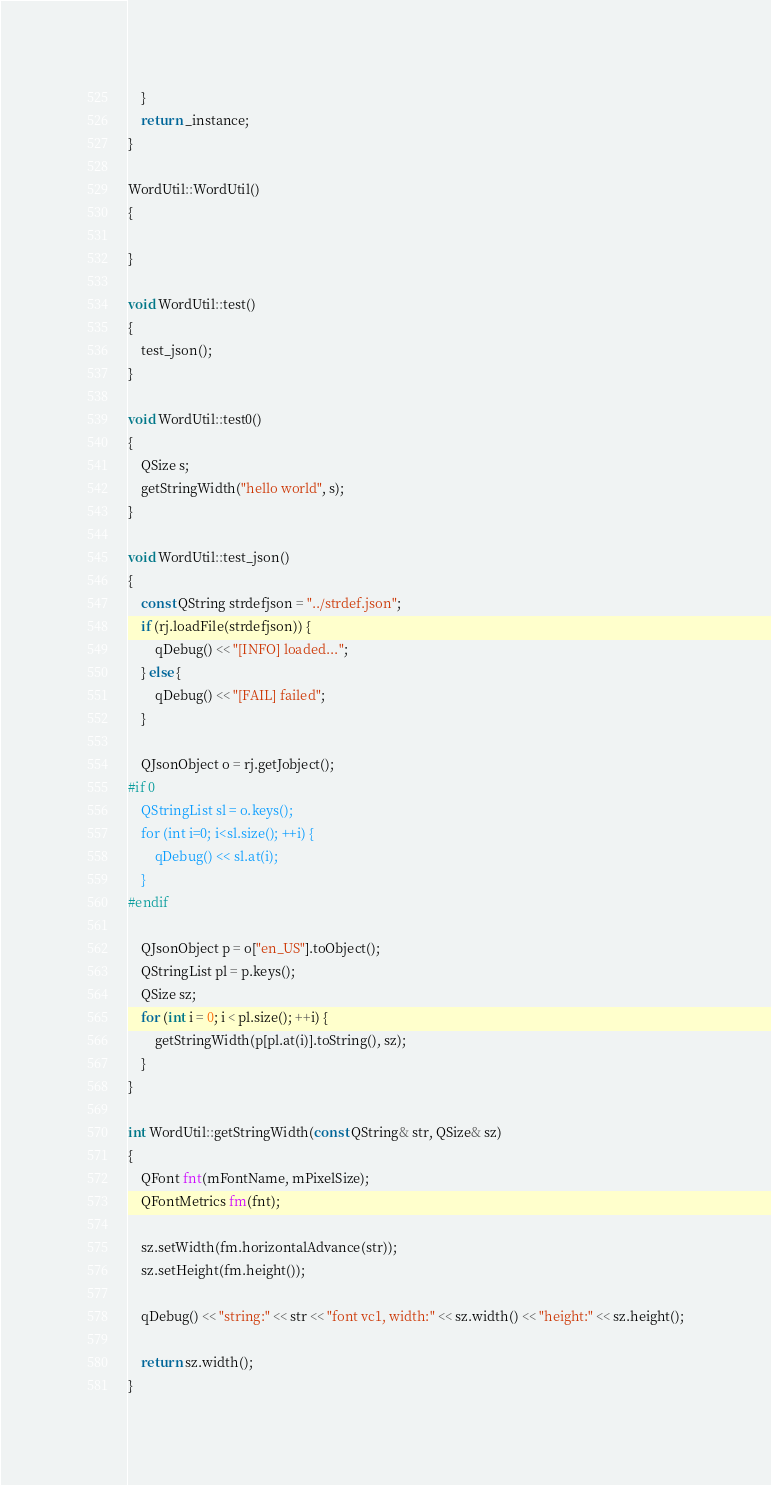<code> <loc_0><loc_0><loc_500><loc_500><_C++_>    }
    return _instance;
}

WordUtil::WordUtil()
{

}

void WordUtil::test()
{
    test_json();
}

void WordUtil::test0()
{
    QSize s;
    getStringWidth("hello world", s);
}

void WordUtil::test_json()
{
    const QString strdefjson = "../strdef.json";
    if (rj.loadFile(strdefjson)) {
        qDebug() << "[INFO] loaded...";
    } else {
        qDebug() << "[FAIL] failed";
    }

    QJsonObject o = rj.getJobject();
#if 0
    QStringList sl = o.keys();
    for (int i=0; i<sl.size(); ++i) {
        qDebug() << sl.at(i);
    }
#endif

    QJsonObject p = o["en_US"].toObject();
    QStringList pl = p.keys();
    QSize sz;
    for (int i = 0; i < pl.size(); ++i) {
        getStringWidth(p[pl.at(i)].toString(), sz);
    }
}

int WordUtil::getStringWidth(const QString& str, QSize& sz)
{
    QFont fnt(mFontName, mPixelSize);
    QFontMetrics fm(fnt);

    sz.setWidth(fm.horizontalAdvance(str));
    sz.setHeight(fm.height());

    qDebug() << "string:" << str << "font vc1, width:" << sz.width() << "height:" << sz.height();

    return sz.width();
}
</code> 